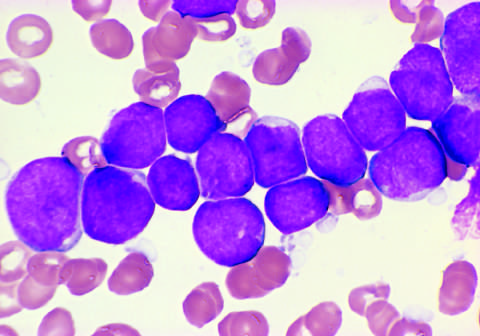re the tumor cells positive for the b cell markers cd19 and cd22?
Answer the question using a single word or phrase. Yes 